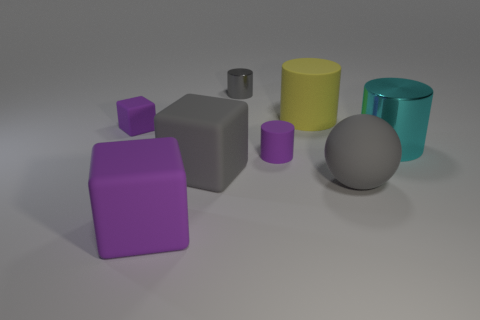Is there anything else that has the same color as the large shiny thing?
Offer a very short reply. No. Are there the same number of large cyan shiny cylinders that are in front of the large cyan shiny thing and gray metallic cylinders that are in front of the tiny purple cylinder?
Provide a succinct answer. Yes. Is the number of yellow objects left of the big yellow cylinder greater than the number of large blue matte spheres?
Your answer should be compact. No. How many things are either gray things that are right of the large gray rubber block or big purple blocks?
Provide a short and direct response. 3. How many spheres have the same material as the big purple thing?
Ensure brevity in your answer.  1. What is the shape of the tiny object that is the same color as the small matte cylinder?
Provide a short and direct response. Cube. Is there a small purple rubber object that has the same shape as the yellow rubber thing?
Offer a terse response. Yes. The yellow thing that is the same size as the cyan shiny cylinder is what shape?
Ensure brevity in your answer.  Cylinder. Does the small rubber cube have the same color as the rubber cube that is right of the large purple cube?
Offer a very short reply. No. There is a rubber cylinder that is behind the tiny purple cube; what number of shiny objects are behind it?
Give a very brief answer. 1. 